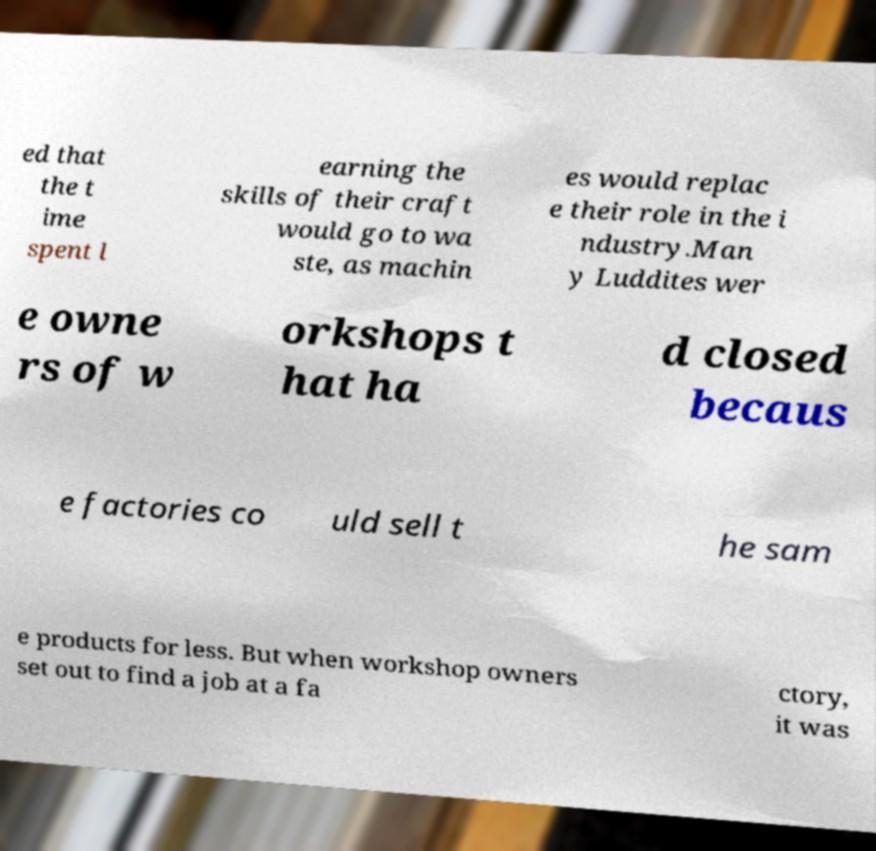Can you read and provide the text displayed in the image?This photo seems to have some interesting text. Can you extract and type it out for me? ed that the t ime spent l earning the skills of their craft would go to wa ste, as machin es would replac e their role in the i ndustry.Man y Luddites wer e owne rs of w orkshops t hat ha d closed becaus e factories co uld sell t he sam e products for less. But when workshop owners set out to find a job at a fa ctory, it was 